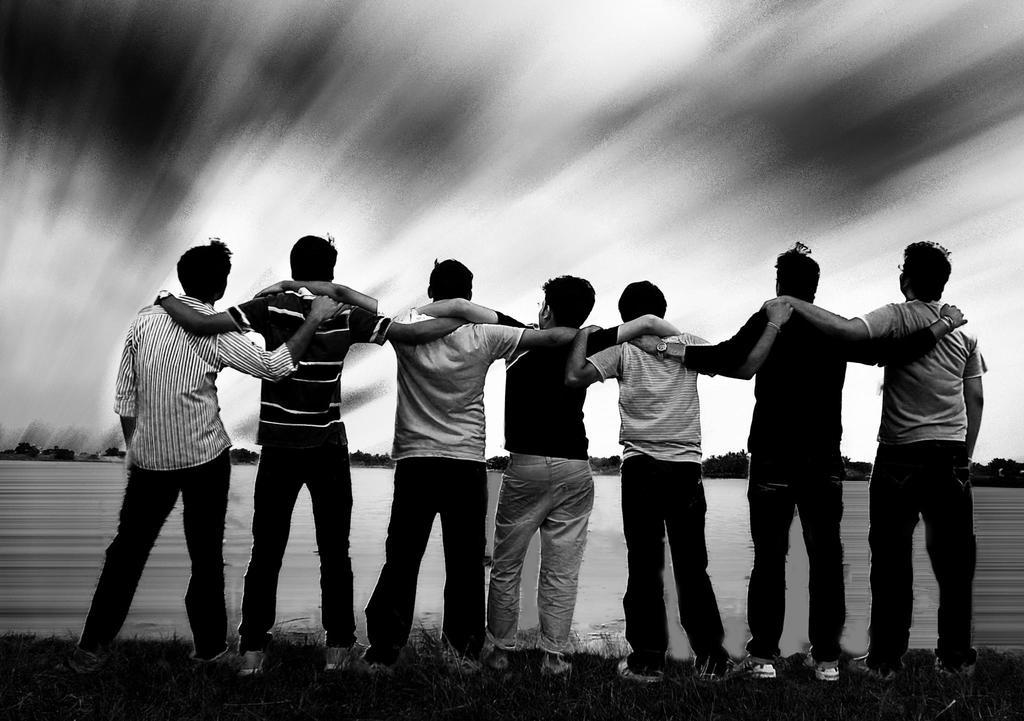What is the main subject of the image? The main subject of the image is a group of men. Where are the men located in the image? The men are standing on the ground. What can be seen in the background of the image? There is water and trees visible in the background of the image. What is the color scheme of the image? The image is black and white in color. How many ears can be seen on the men in the image? There is no way to determine the number of ears on the men in the image, as the image is black and white and does not provide enough detail to count individual body parts. 